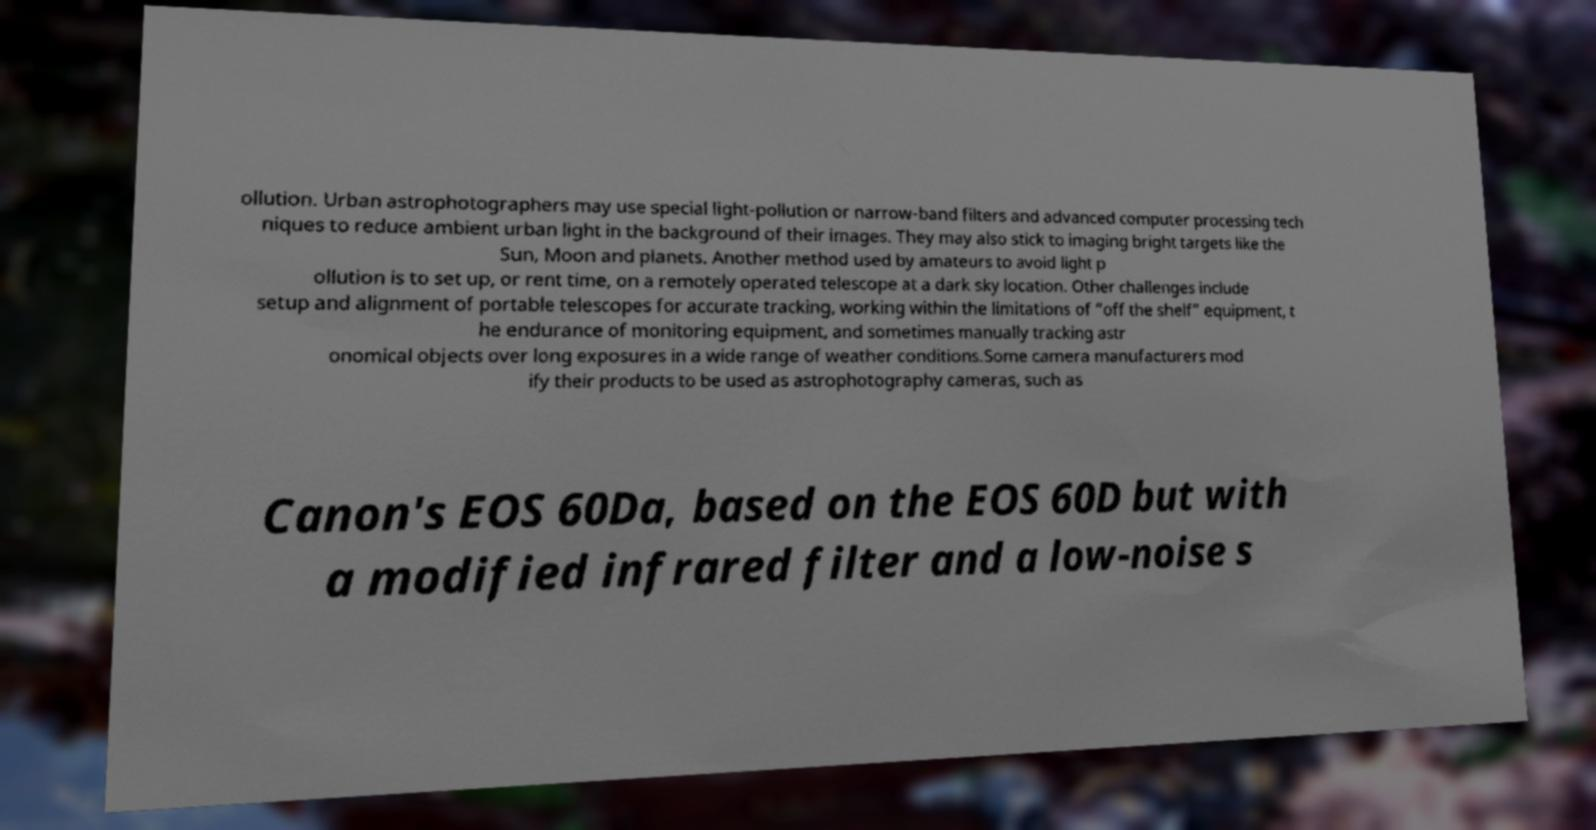I need the written content from this picture converted into text. Can you do that? ollution. Urban astrophotographers may use special light-pollution or narrow-band filters and advanced computer processing tech niques to reduce ambient urban light in the background of their images. They may also stick to imaging bright targets like the Sun, Moon and planets. Another method used by amateurs to avoid light p ollution is to set up, or rent time, on a remotely operated telescope at a dark sky location. Other challenges include setup and alignment of portable telescopes for accurate tracking, working within the limitations of “off the shelf” equipment, t he endurance of monitoring equipment, and sometimes manually tracking astr onomical objects over long exposures in a wide range of weather conditions.Some camera manufacturers mod ify their products to be used as astrophotography cameras, such as Canon's EOS 60Da, based on the EOS 60D but with a modified infrared filter and a low-noise s 